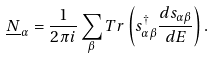Convert formula to latex. <formula><loc_0><loc_0><loc_500><loc_500>\underline { N } _ { \alpha } = \frac { 1 } { 2 \pi i } \sum _ { \beta } T r \left ( s _ { \alpha \beta } ^ { \dagger } \frac { d s _ { \alpha \beta } } { d E } \right ) .</formula> 